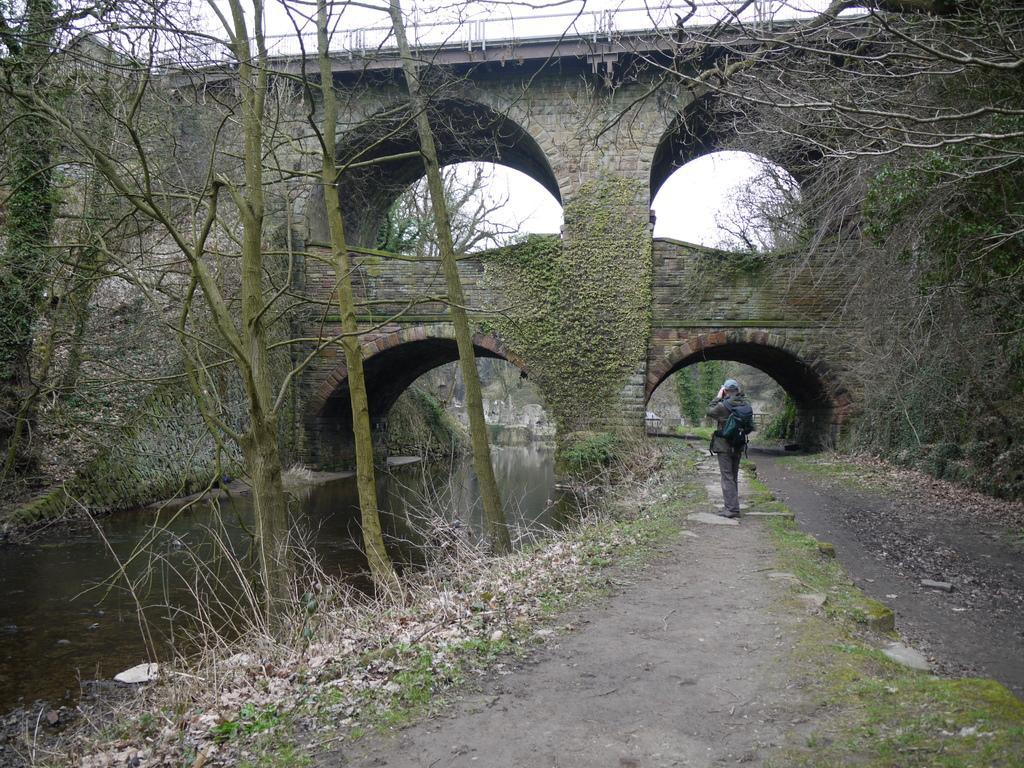In one or two sentences, can you explain what this image depicts? In this image we can see a person standing on the ground, wearing a bag, there is a bridge in front of him, we can see some trees and a flowing river. 